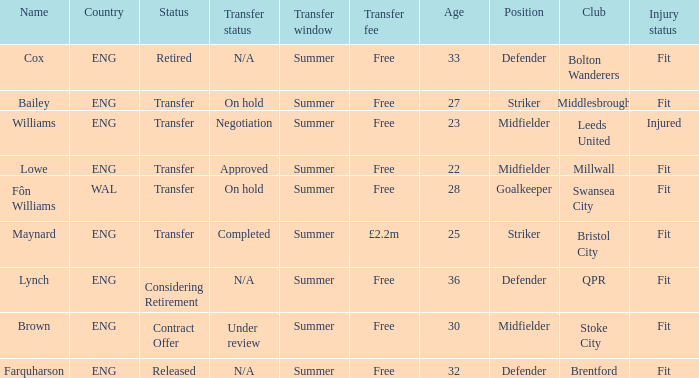What is the transfer window with a status of transfer from the country of Wal? Summer. 